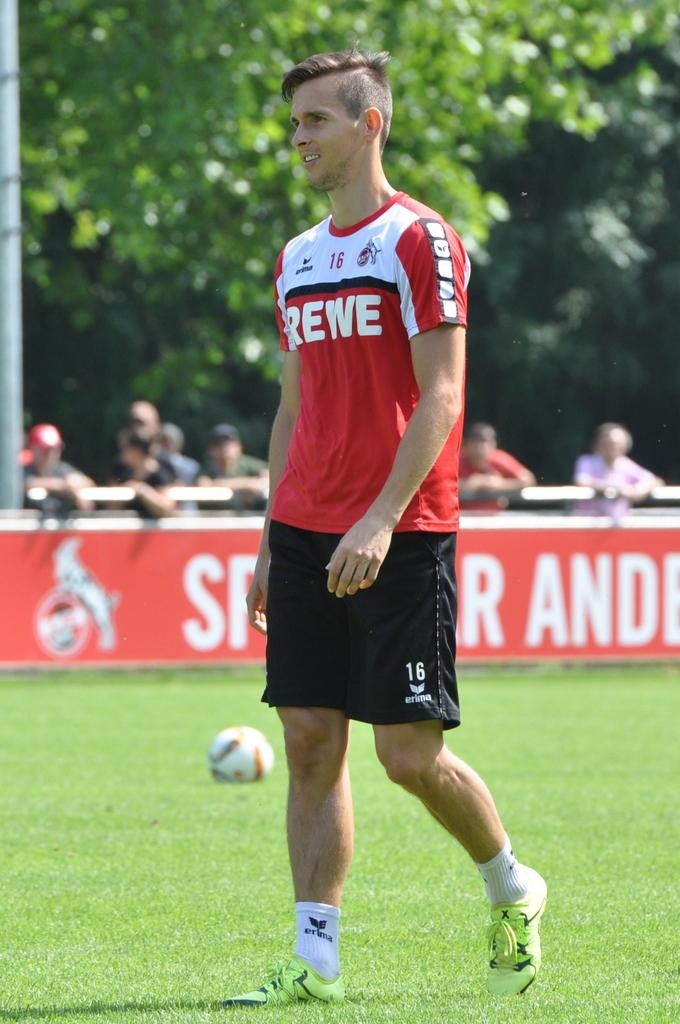What is the man in the image wearing? The man is wearing a red t-shirt. What is the man doing in the image? The man is standing on the ground. What object can be seen in the image besides the man? There is a ball in the image. Who else is present in the image? There is a group of people standing in the image. What type of natural scenery is visible in the image? There are trees in the image. How many flags are being waved by the group of people in the image? There is no mention of flags in the image, so it is impossible to determine how many are being waved. 